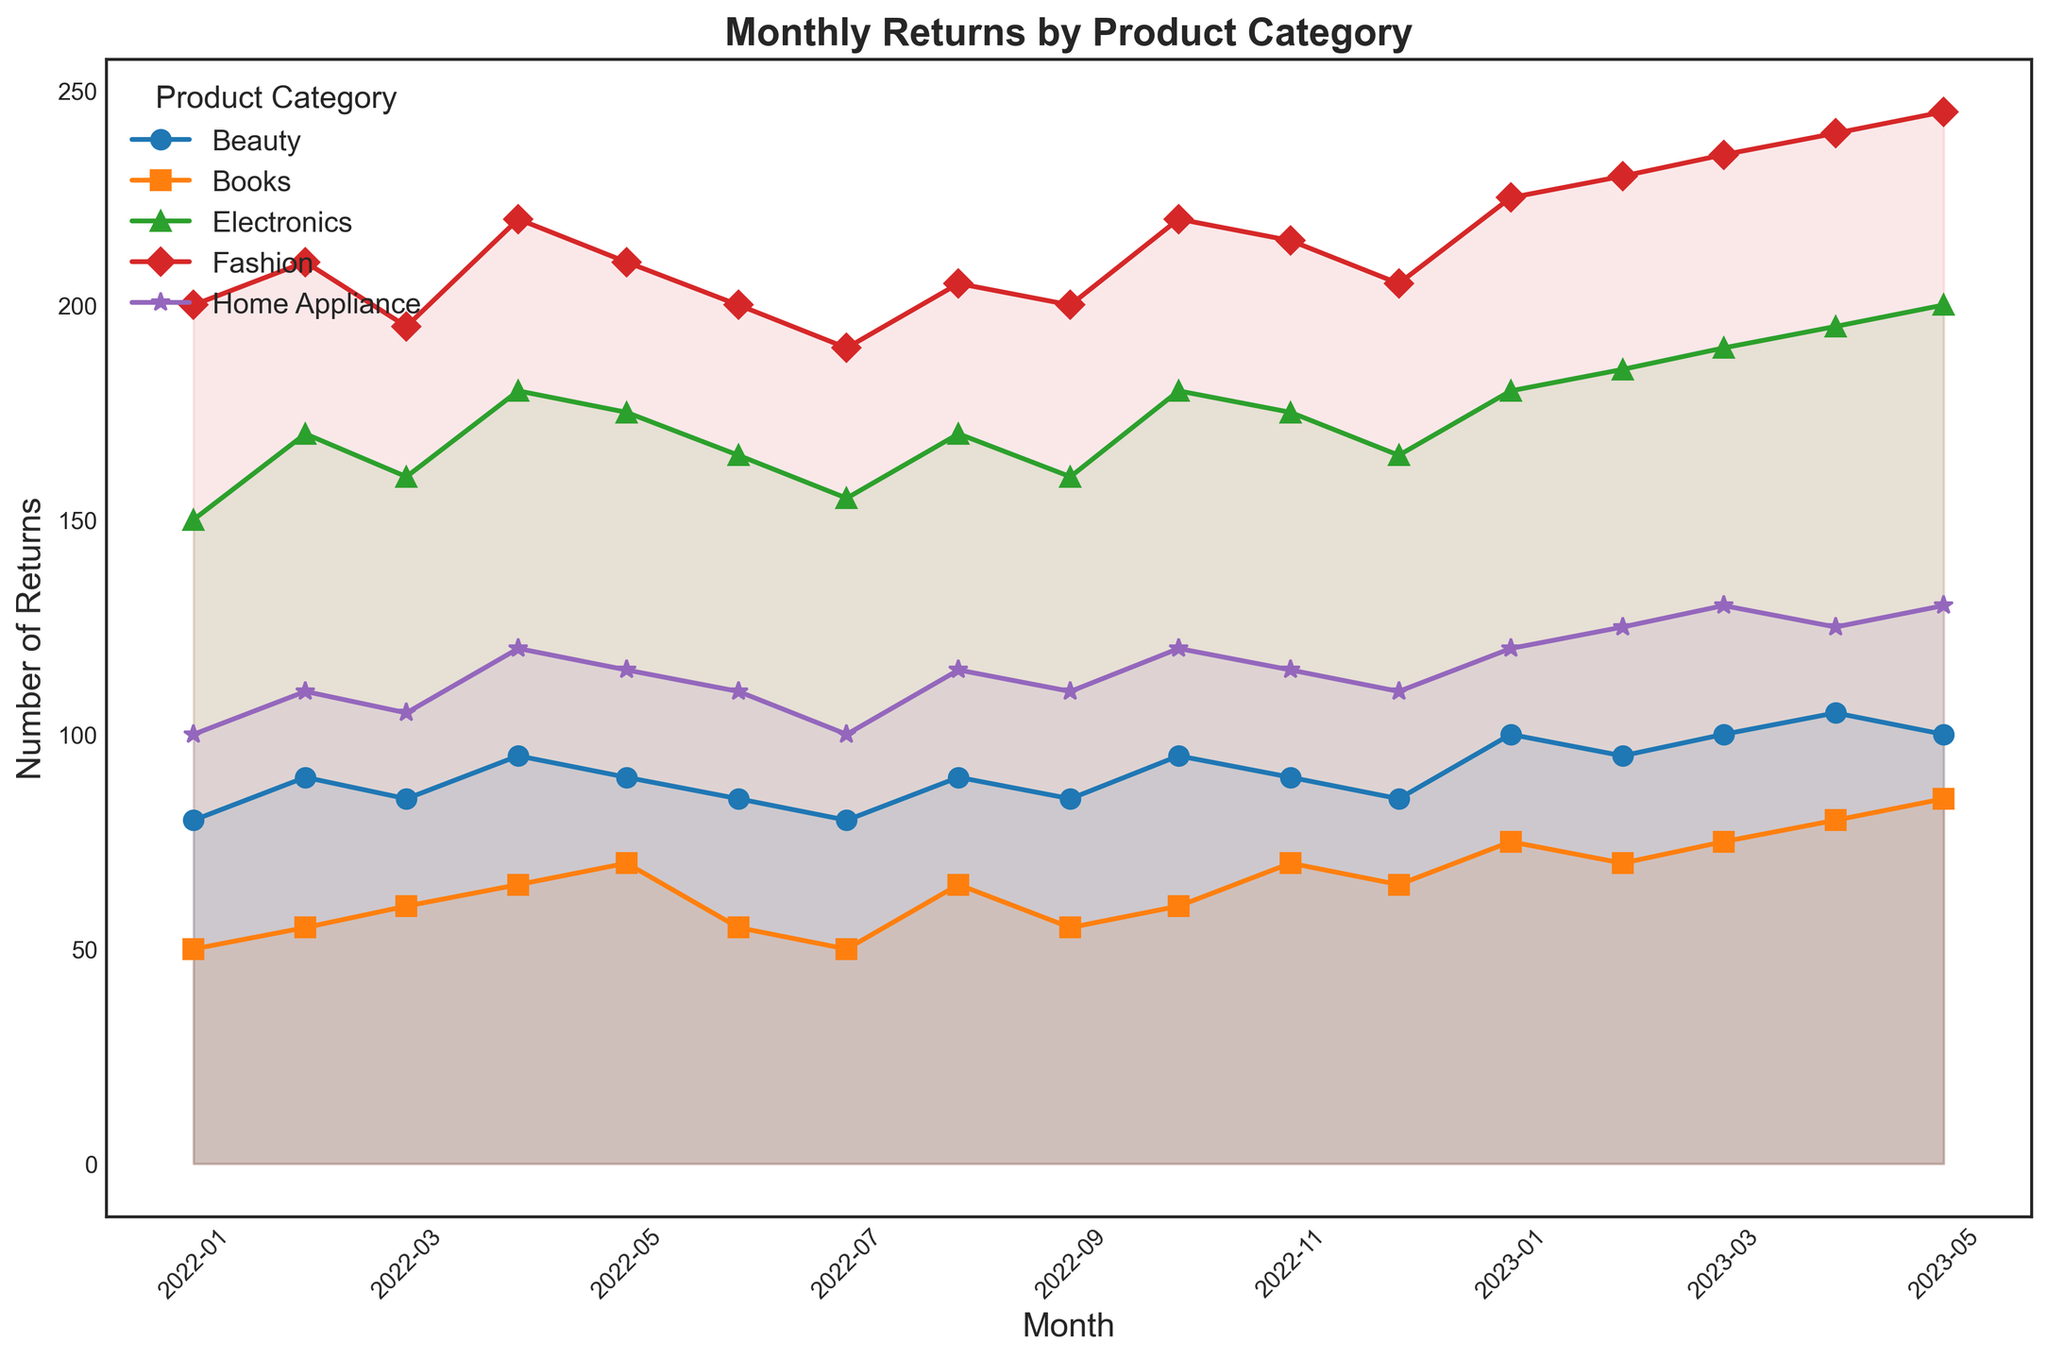What month had the highest number of returns for Electronics, and what was that number? Observe the peaks in each line. The highest point for Electronics is in May 2023 with 200 returns.
Answer: May 2023, 200 Which product category had the lowest number of returns in December 2022, and what was that number? Look at the December 2022 data points for each category and identify the lowest. Beauty had the lowest returns at 85.
Answer: Beauty, 85 How does the trend of Fashion returns from January 2022 to May 2023 compare to that of Books in the same period? Compare the overall shape and direction of the two lines. Fashion shows a consistent increase, while Books show a slight increase over the same period.
Answer: Fashion increases consistently; Books increase slightly What is the difference in the number of returns between Electronics and Home Appliance in April 2023? Find the data points for April 2023 for both categories and subtract the Home Appliance value from the Electronics value. Electronics had 195 returns and Home Appliance had 125, so the difference is 195 - 125 = 70.
Answer: 70 In which month did Beauty see its highest number of returns, and how many returns were recorded? Identify the peak in the Beauty line. The highest point is April 2023 with 105 returns.
Answer: April 2023, 105 If you sum the returns for Fashion in January 2023 and February 2023, what is the total? Add the returns for Fashion in these two months: 225 (January) + 230 (February) = 455.
Answer: 455 What is the average number of returns for Home Appliance in the first quarter of 2023? Add January, February, and March values for Home Appliance and divide by 3: (120 + 125 + 130) / 3 = 125.
Answer: 125 Between which two consecutive months did Electronics see the largest increase in returns, and what was the increase? Observe the line and look for the steepest upward change. The largest increase is from December 2022 to January 2023, increasing by 180 - 165 = 15.
Answer: December 2022 to January 2023, 15 What visual pattern can you observe for the Book category's return trends? Describe the general visual trend. Books show a relatively stable pattern with slight increases and minor fluctuations.
Answer: Stable with slight increases 